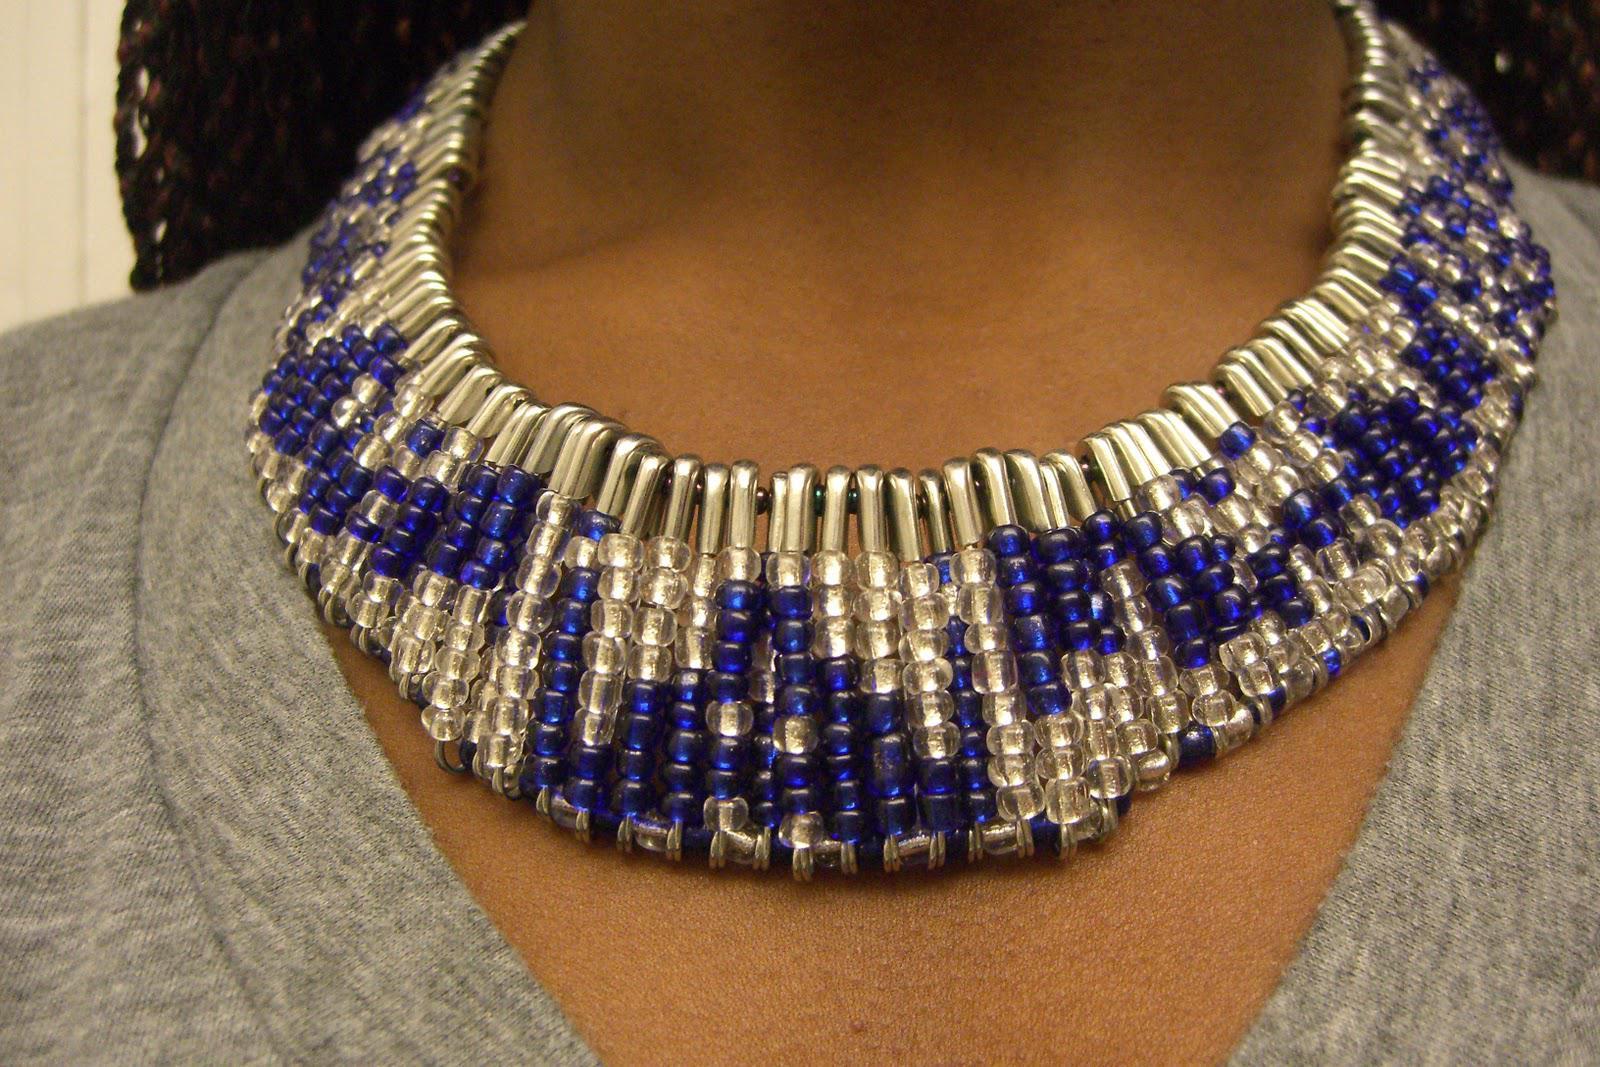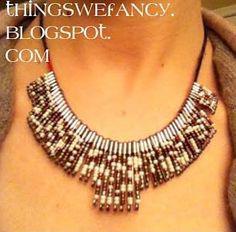The first image is the image on the left, the second image is the image on the right. Analyze the images presented: Is the assertion "One of the necklaces is not dangling around a neck." valid? Answer yes or no. No. The first image is the image on the left, the second image is the image on the right. Examine the images to the left and right. Is the description "Both images show a model wearing a necklace." accurate? Answer yes or no. Yes. 